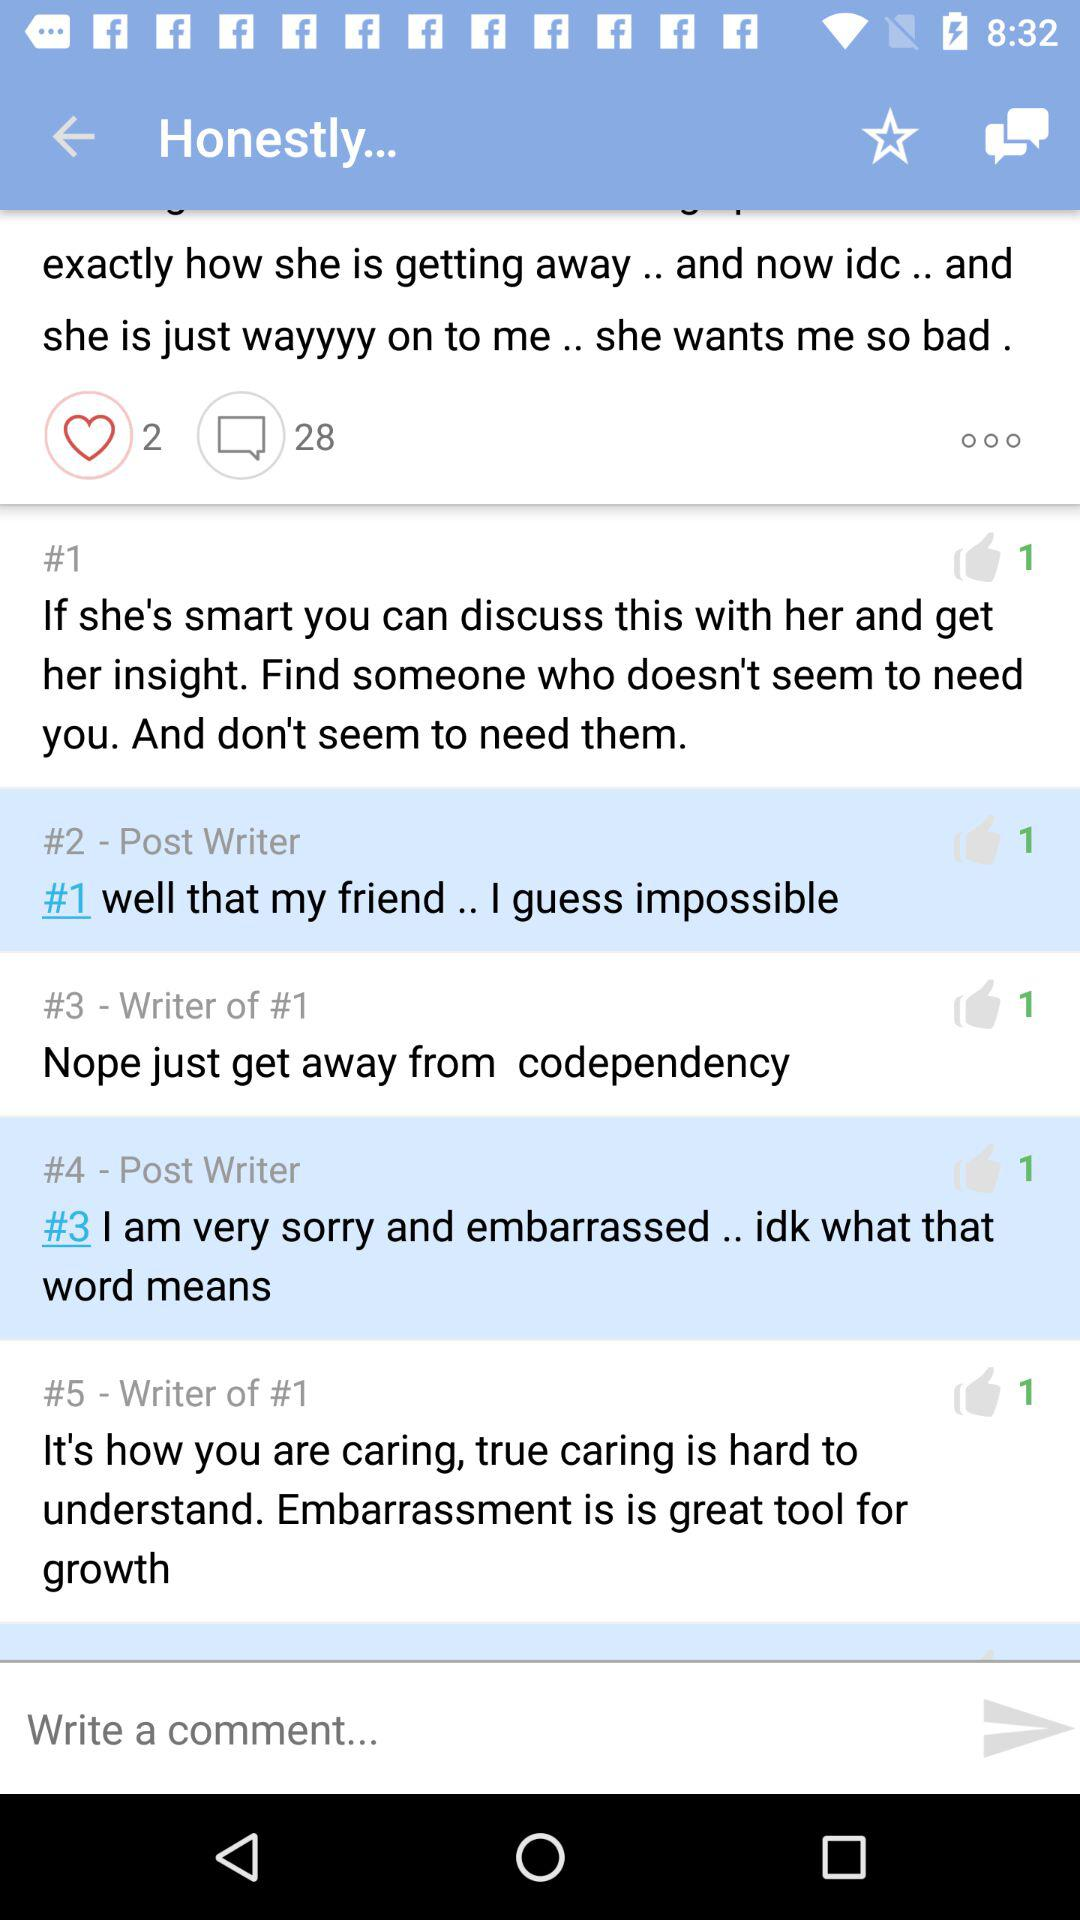How many comments in total are there? There are 28 comments in total. 